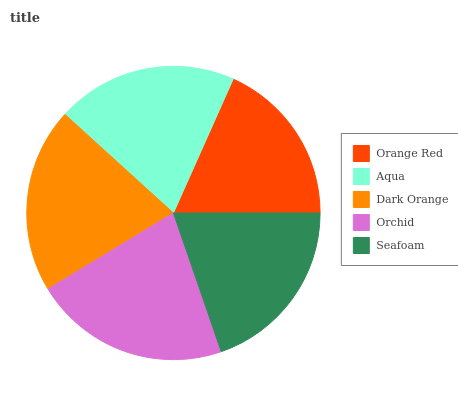Is Orange Red the minimum?
Answer yes or no. Yes. Is Orchid the maximum?
Answer yes or no. Yes. Is Aqua the minimum?
Answer yes or no. No. Is Aqua the maximum?
Answer yes or no. No. Is Aqua greater than Orange Red?
Answer yes or no. Yes. Is Orange Red less than Aqua?
Answer yes or no. Yes. Is Orange Red greater than Aqua?
Answer yes or no. No. Is Aqua less than Orange Red?
Answer yes or no. No. Is Aqua the high median?
Answer yes or no. Yes. Is Aqua the low median?
Answer yes or no. Yes. Is Orange Red the high median?
Answer yes or no. No. Is Dark Orange the low median?
Answer yes or no. No. 